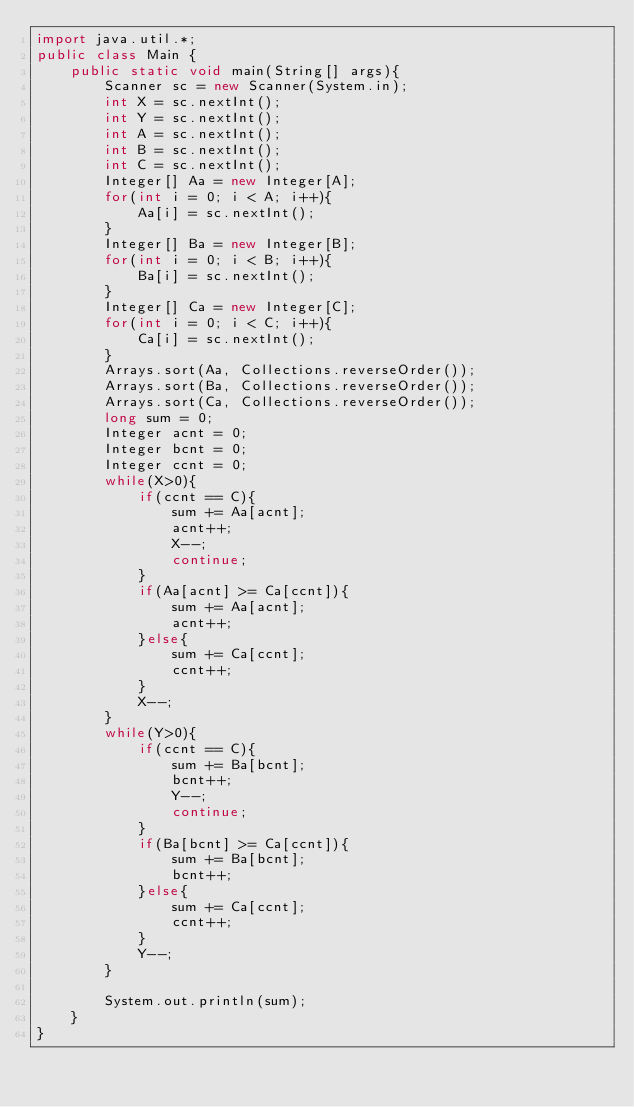Convert code to text. <code><loc_0><loc_0><loc_500><loc_500><_Java_>import java.util.*;
public class Main {
	public static void main(String[] args){
		Scanner sc = new Scanner(System.in);
		int X = sc.nextInt();
      	int Y = sc.nextInt();
      	int A = sc.nextInt();
      	int B = sc.nextInt();
     	int C = sc.nextInt();
        Integer[] Aa = new Integer[A];
      	for(int i = 0; i < A; i++){
        	Aa[i] = sc.nextInt();
        }
      	Integer[] Ba = new Integer[B];
      	for(int i = 0; i < B; i++){
        	Ba[i] = sc.nextInt();
        }
      	Integer[] Ca = new Integer[C];
      	for(int i = 0; i < C; i++){
        	Ca[i] = sc.nextInt();
        }
      	Arrays.sort(Aa, Collections.reverseOrder());
      	Arrays.sort(Ba, Collections.reverseOrder());
      	Arrays.sort(Ca, Collections.reverseOrder());
		long sum = 0;
      	Integer acnt = 0;
      	Integer bcnt = 0;
      	Integer ccnt = 0;
      	while(X>0){
          	if(ccnt == C){
              	sum += Aa[acnt];
                acnt++;
            	X--;
              	continue;
            }
          	if(Aa[acnt] >= Ca[ccnt]){
              	sum += Aa[acnt];
              	acnt++;
            }else{
            	sum += Ca[ccnt];
              	ccnt++;
            }
        	X--;
        }
      	while(Y>0){
            if(ccnt == C){
              	sum += Ba[bcnt];
                bcnt++;
            	Y--;
              	continue;
            }
          	if(Ba[bcnt] >= Ca[ccnt]){
              	sum += Ba[bcnt];
              	bcnt++;
            }else{
            	sum += Ca[ccnt];
              	ccnt++;
            }
        	Y--;
        }
      
		System.out.println(sum);
	}
}</code> 